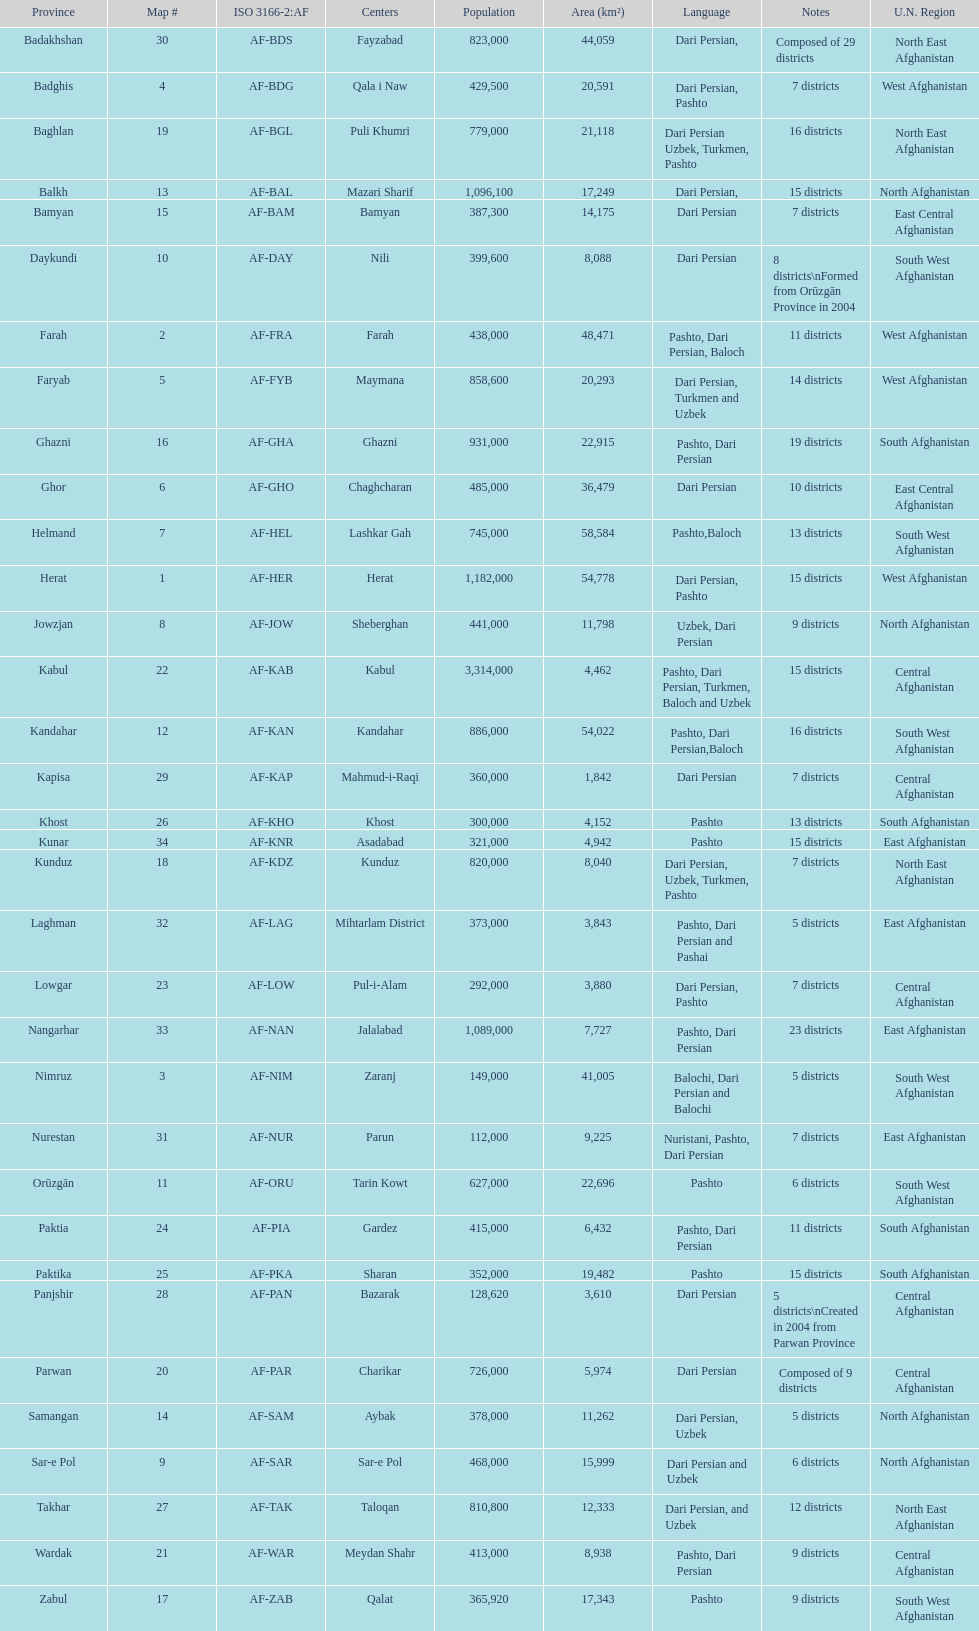Give the province with the least population Nurestan. 